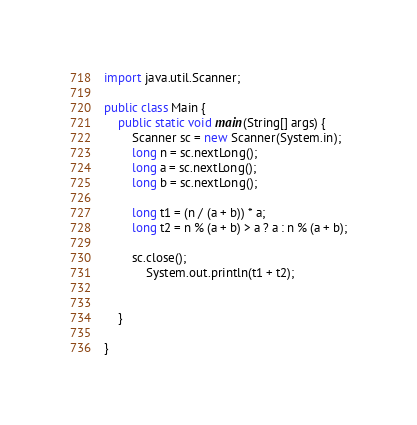<code> <loc_0><loc_0><loc_500><loc_500><_Java_>import java.util.Scanner;

public class Main {
	public static void main(String[] args) {
		Scanner sc = new Scanner(System.in);
		long n = sc.nextLong();
		long a = sc.nextLong();
		long b = sc.nextLong();

		long t1 = (n / (a + b)) * a;
		long t2 = n % (a + b) > a ? a : n % (a + b);

		sc.close();
			System.out.println(t1 + t2);


	}

}
</code> 